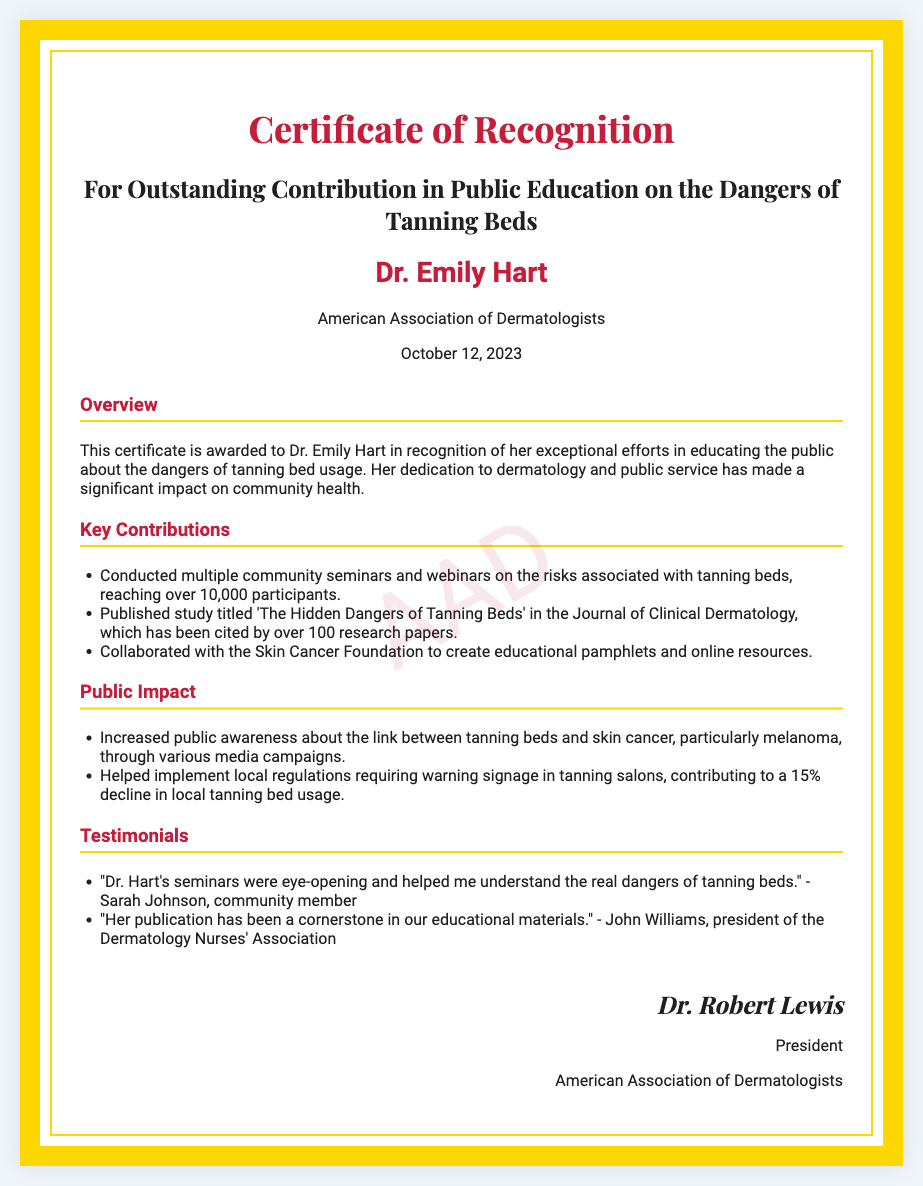What is the title of the certificate? The title of the certificate is the main heading found at the top of the document, stating its purpose and recognition.
Answer: Certificate of Recognition Who is the recipient of the certificate? The recipient's name is prominently displayed in the document, indicating the individual being honored.
Answer: Dr. Emily Hart What organization awarded the certificate? The awarding organization is mentioned below the recipient's name, indicating the authority granting the recognition.
Answer: American Association of Dermatologists What date was the certificate awarded? The award date is clearly stated in the document, providing the specific day the recognition was given.
Answer: October 12, 2023 How many participants did Dr. Hart reach through her seminars? The document specifies the number of participants in the seminars conducted by Dr. Hart, reflecting her outreach efforts.
Answer: over 10,000 participants What was the title of Dr. Hart's published study? The title of the publication is mentioned in the 'Key Contributions' section and highlights her research work.
Answer: The Hidden Dangers of Tanning Beds What percentage decline in local tanning bed usage was contributed by Dr. Hart? The document mentions the impact Dr. Hart's efforts had on local tanning bed usage, showing the effectiveness of her actions.
Answer: 15% Who provided a testimonial praising Dr. Hart's seminars? The document includes testimonials from community members, and one specific individual is quoted in recognition of her contributions.
Answer: Sarah Johnson What is the name of the president who signed the certificate? The president's name is included in the signatory section, indicating the authority behind the certificate's issuance.
Answer: Dr. Robert Lewis 